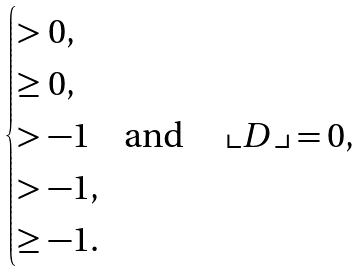<formula> <loc_0><loc_0><loc_500><loc_500>\begin{cases} > 0 , \\ \geq 0 , \\ > - 1 \quad \text {and \quad $\llcorner D\lrcorner =0$,} \\ > - 1 , \\ \geq - 1 . \\ \end{cases}</formula> 